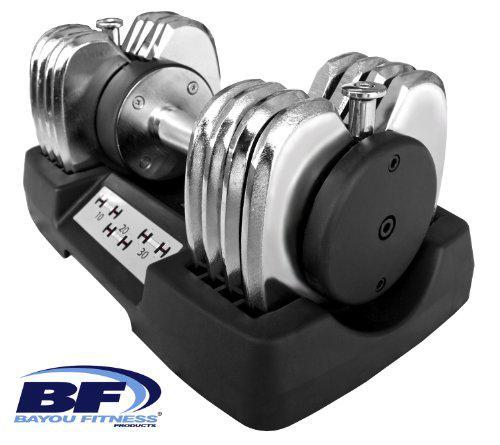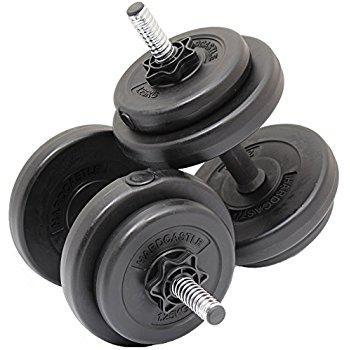The first image is the image on the left, the second image is the image on the right. Evaluate the accuracy of this statement regarding the images: "There are exactly three weights with no bars sticking out of them.". Is it true? Answer yes or no. No. The first image is the image on the left, the second image is the image on the right. Analyze the images presented: Is the assertion "There are 3 dumbbells, and all of them are on storage trays." valid? Answer yes or no. No. 